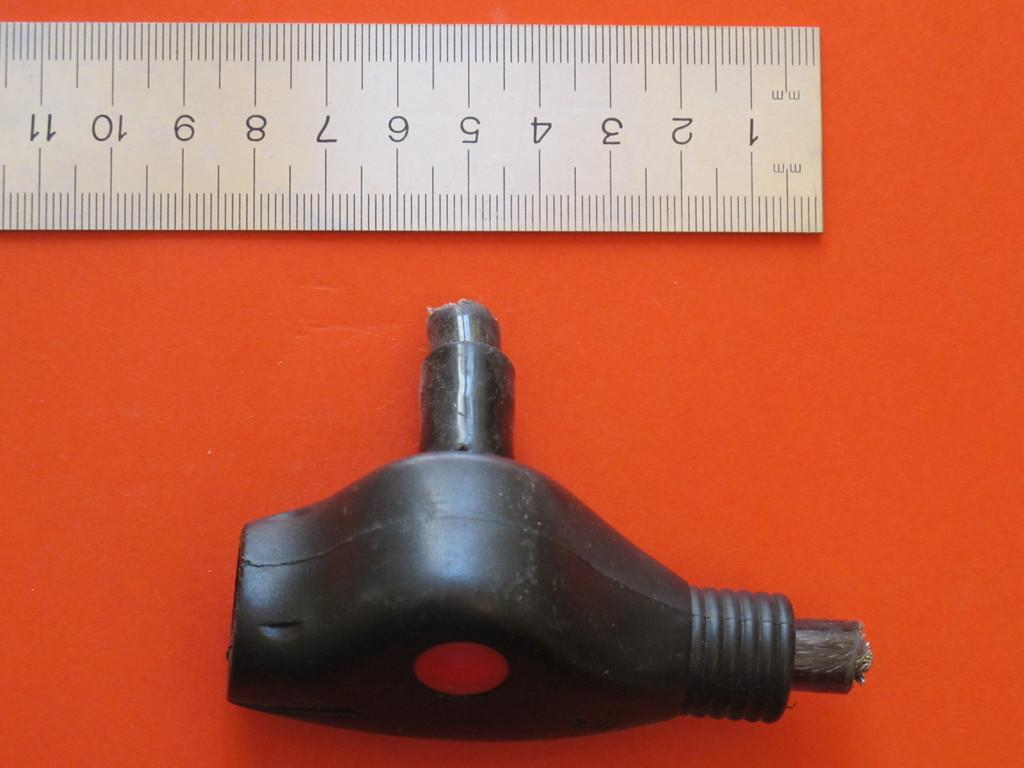What object is located at the bottom of the image? There is a plastic thing in black color at the bottom of the image. What can be seen at the top of the image? There is a scale at the top of the image. How many tickets are visible in the image? There are no tickets present in the image. What type of yarn is being used on the scale in the image? There is no yarn present in the image; it features a scale and a plastic object in black color. 